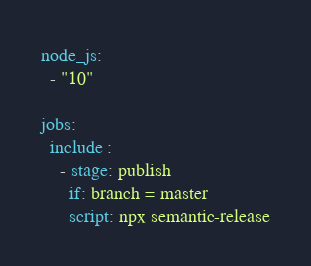Convert code to text. <code><loc_0><loc_0><loc_500><loc_500><_YAML_>node_js: 
  - "10"

jobs: 
  include :
    - stage: publish
      if: branch = master
      script: npx semantic-release
</code> 